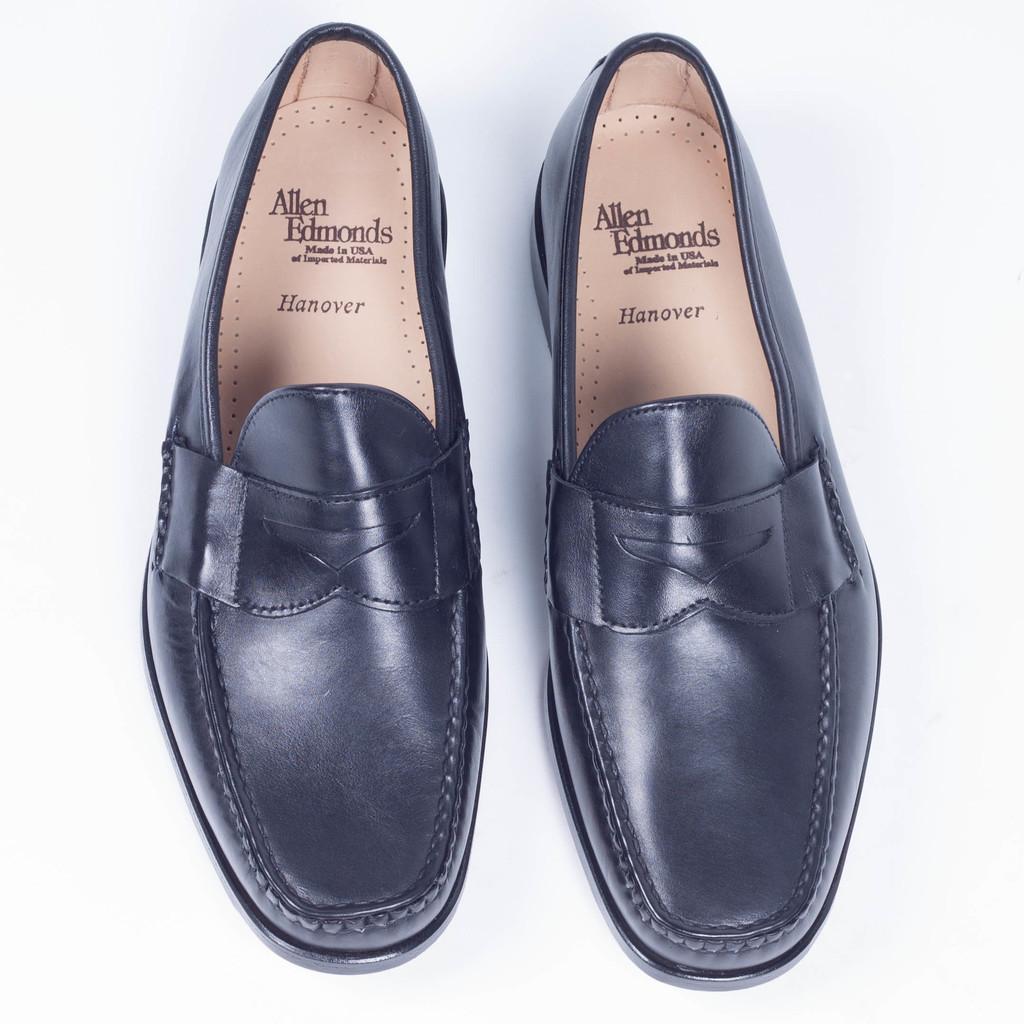Describe this image in one or two sentences. In this image I can see the shoes which are in black and brown color. These are on the white color surface. 